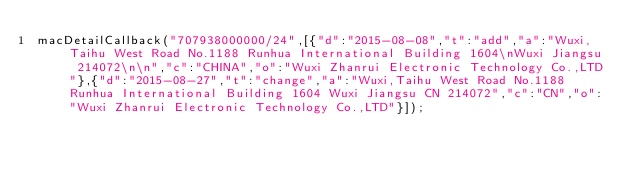<code> <loc_0><loc_0><loc_500><loc_500><_JavaScript_>macDetailCallback("707938000000/24",[{"d":"2015-08-08","t":"add","a":"Wuxi,Taihu West Road No.1188 Runhua International Building 1604\nWuxi Jiangsu 214072\n\n","c":"CHINA","o":"Wuxi Zhanrui Electronic Technology Co.,LTD"},{"d":"2015-08-27","t":"change","a":"Wuxi,Taihu West Road No.1188 Runhua International Building 1604 Wuxi Jiangsu CN 214072","c":"CN","o":"Wuxi Zhanrui Electronic Technology Co.,LTD"}]);
</code> 